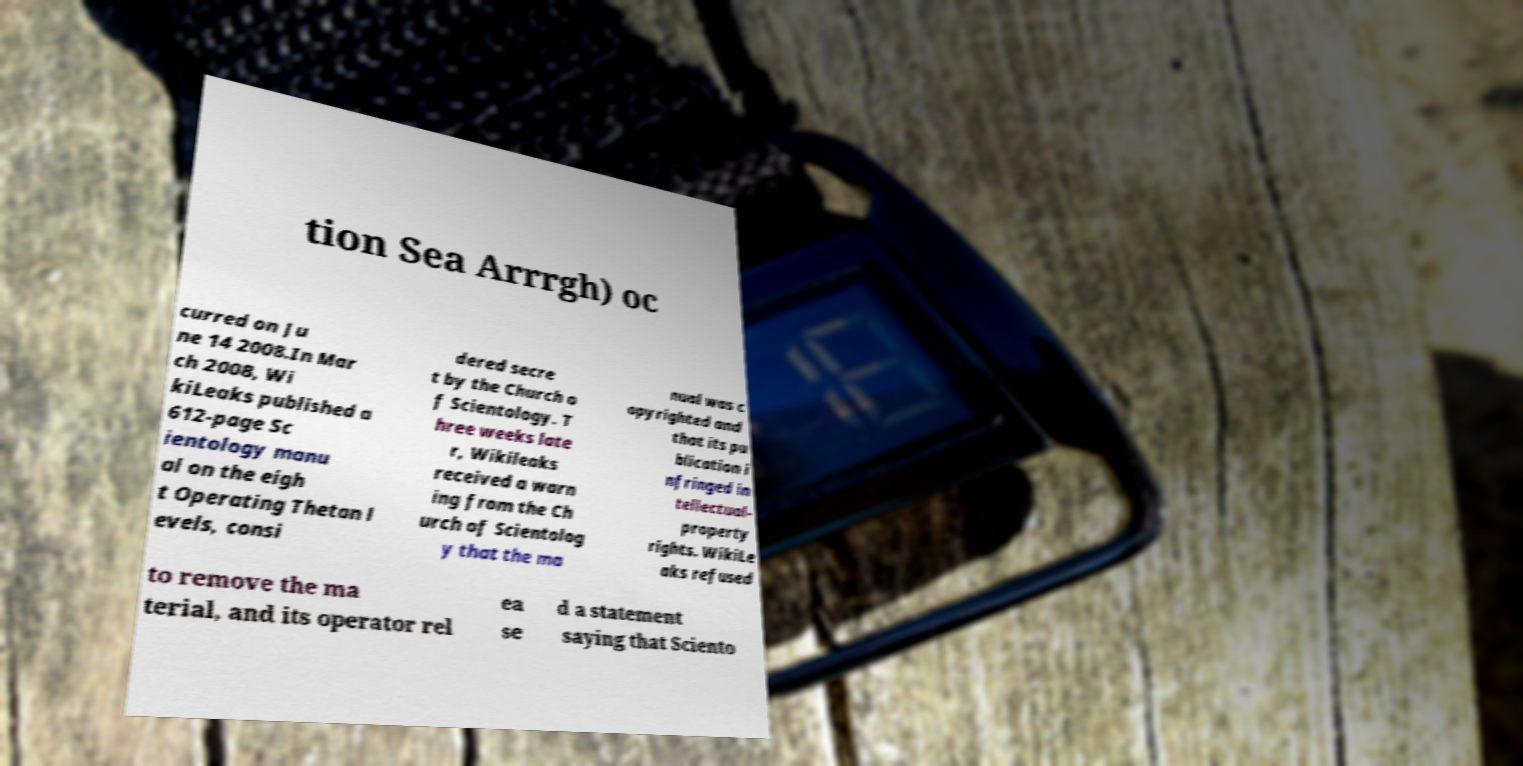Could you assist in decoding the text presented in this image and type it out clearly? tion Sea Arrrgh) oc curred on Ju ne 14 2008.In Mar ch 2008, Wi kiLeaks published a 612-page Sc ientology manu al on the eigh t Operating Thetan l evels, consi dered secre t by the Church o f Scientology. T hree weeks late r, Wikileaks received a warn ing from the Ch urch of Scientolog y that the ma nual was c opyrighted and that its pu blication i nfringed in tellectual- property rights. WikiLe aks refused to remove the ma terial, and its operator rel ea se d a statement saying that Sciento 